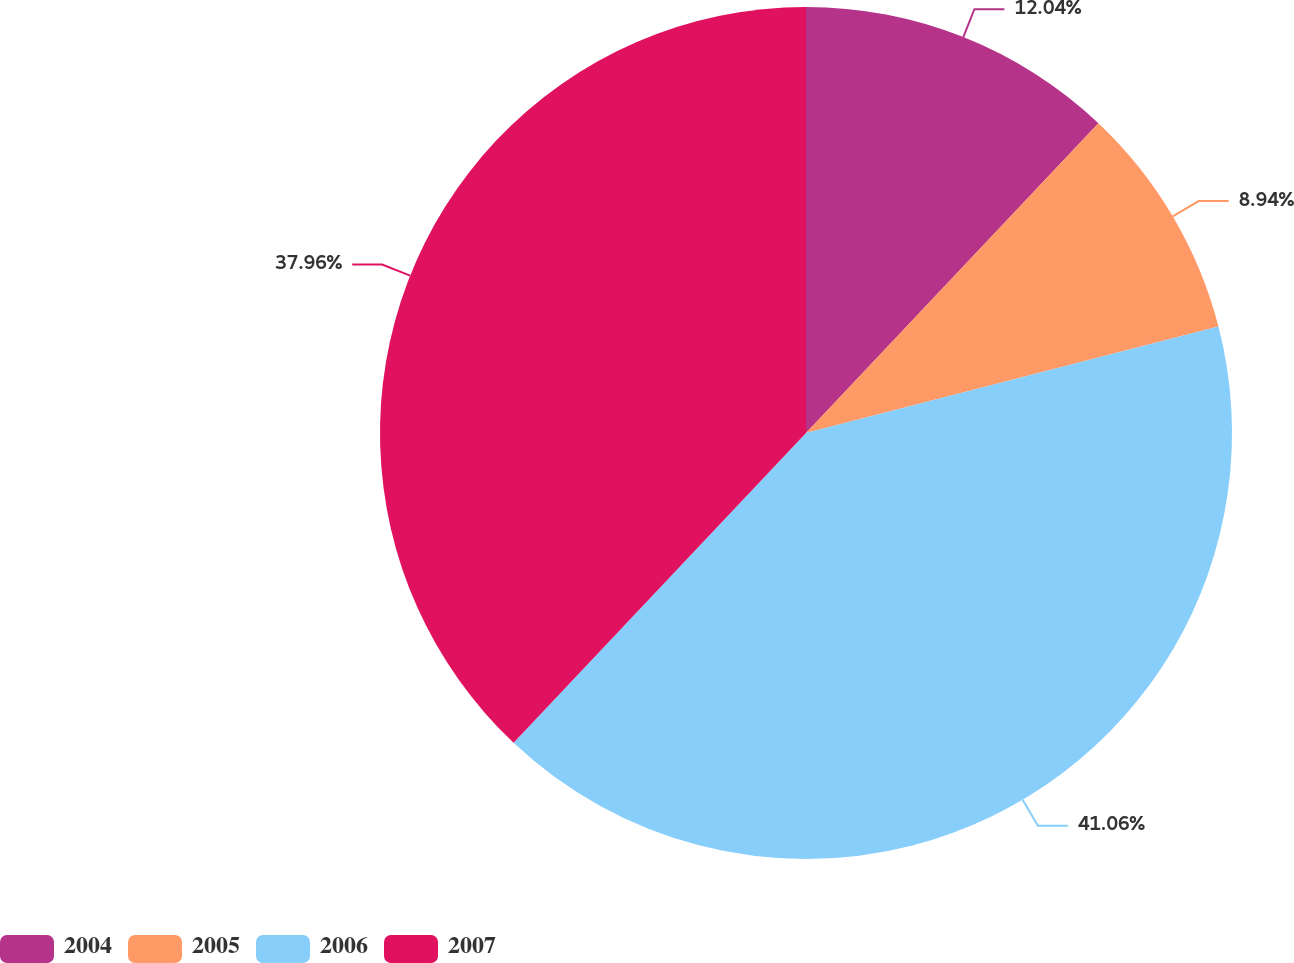<chart> <loc_0><loc_0><loc_500><loc_500><pie_chart><fcel>2004<fcel>2005<fcel>2006<fcel>2007<nl><fcel>12.04%<fcel>8.94%<fcel>41.06%<fcel>37.96%<nl></chart> 